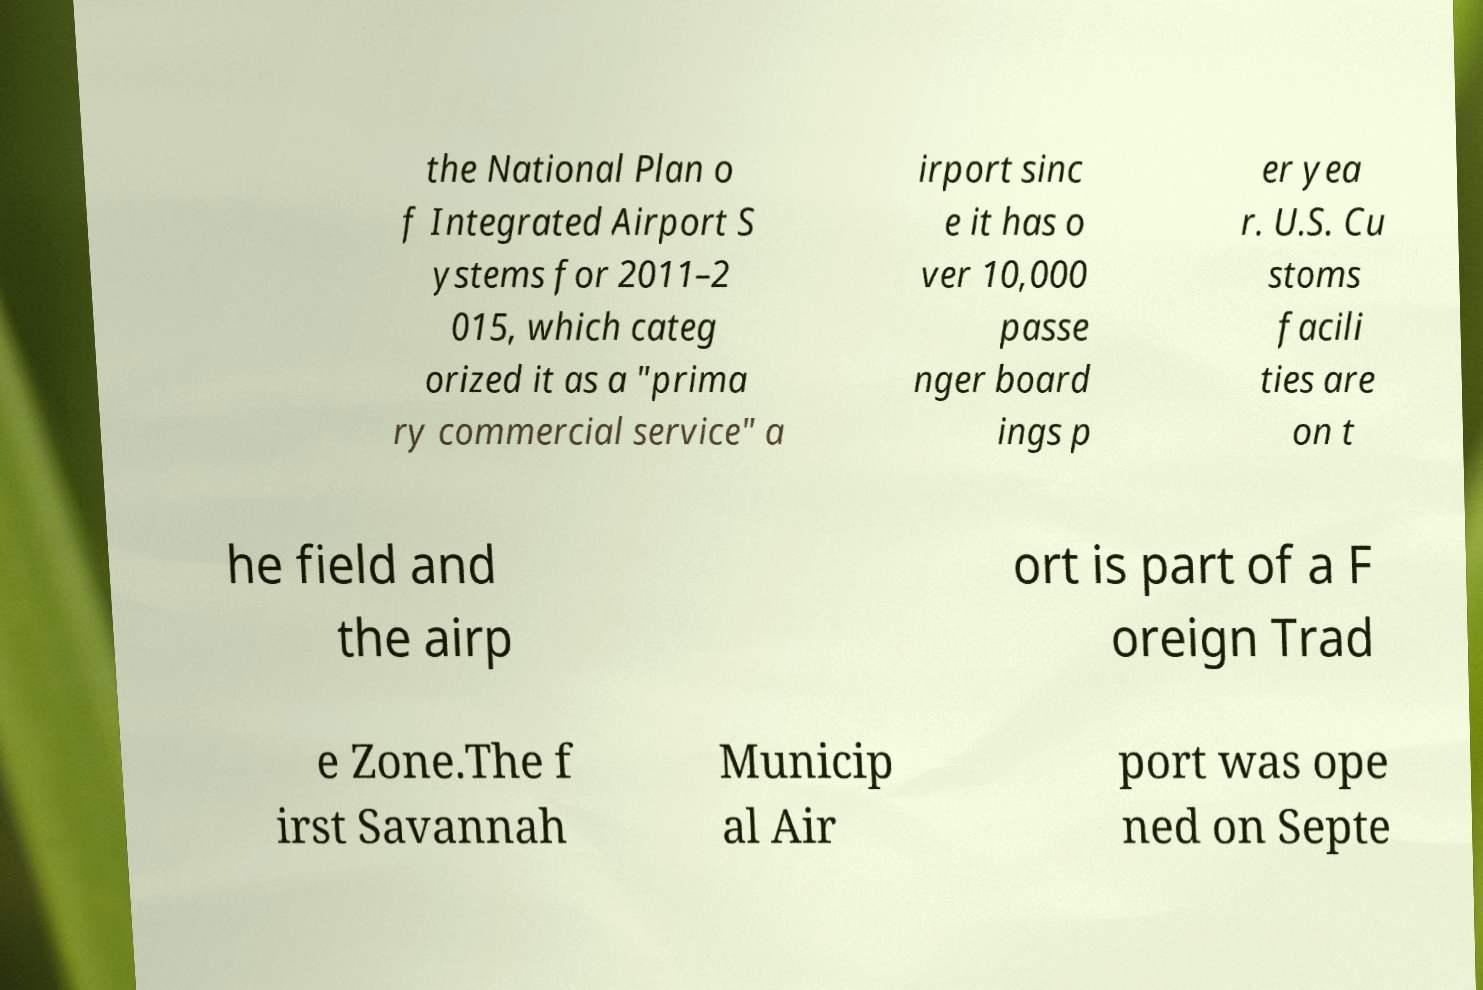Please read and relay the text visible in this image. What does it say? the National Plan o f Integrated Airport S ystems for 2011–2 015, which categ orized it as a "prima ry commercial service" a irport sinc e it has o ver 10,000 passe nger board ings p er yea r. U.S. Cu stoms facili ties are on t he field and the airp ort is part of a F oreign Trad e Zone.The f irst Savannah Municip al Air port was ope ned on Septe 